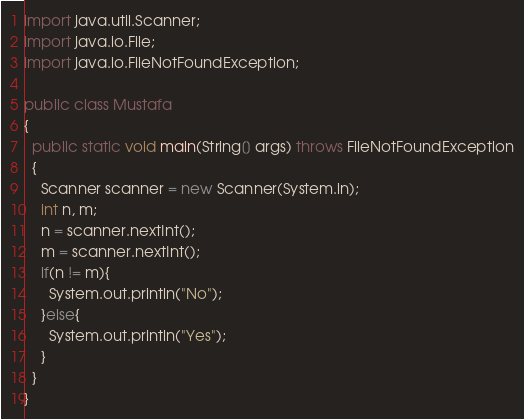<code> <loc_0><loc_0><loc_500><loc_500><_Java_>import java.util.Scanner;
import java.io.File;
import java.io.FileNotFoundException;

public class Mustafa
{
  public static void main(String[] args) throws FileNotFoundException
  {
    Scanner scanner = new Scanner(System.in);
    int n, m;
    n = scanner.nextInt();
    m = scanner.nextInt();
    if(n != m){
      System.out.println("No");
    }else{
      System.out.println("Yes");
    }
  }
}
</code> 